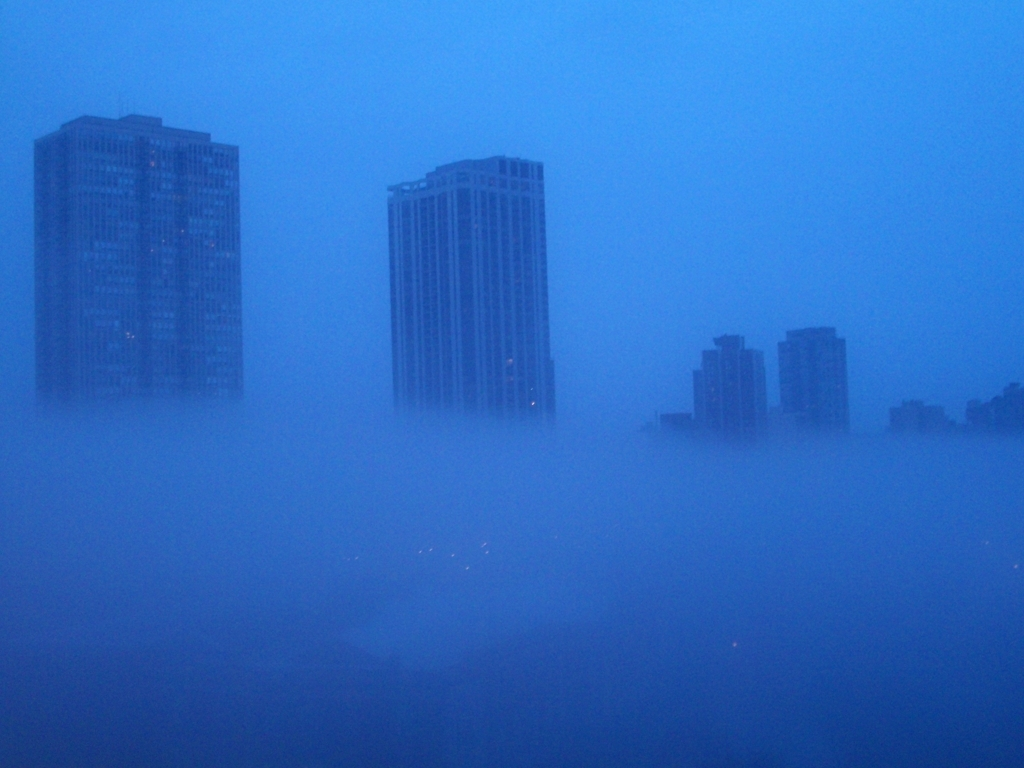What emotions might this image evoke in a viewer? The image could evoke a sense of tranquility and isolation due to the fog's ability to mute the usual bustling city atmosphere. Some might feel a touch of melancholy or reflection, as the obscured cityscape can prompt introspection. Others might find the scene mystical or serene, akin to a moment of calm in the midst of urban life. 